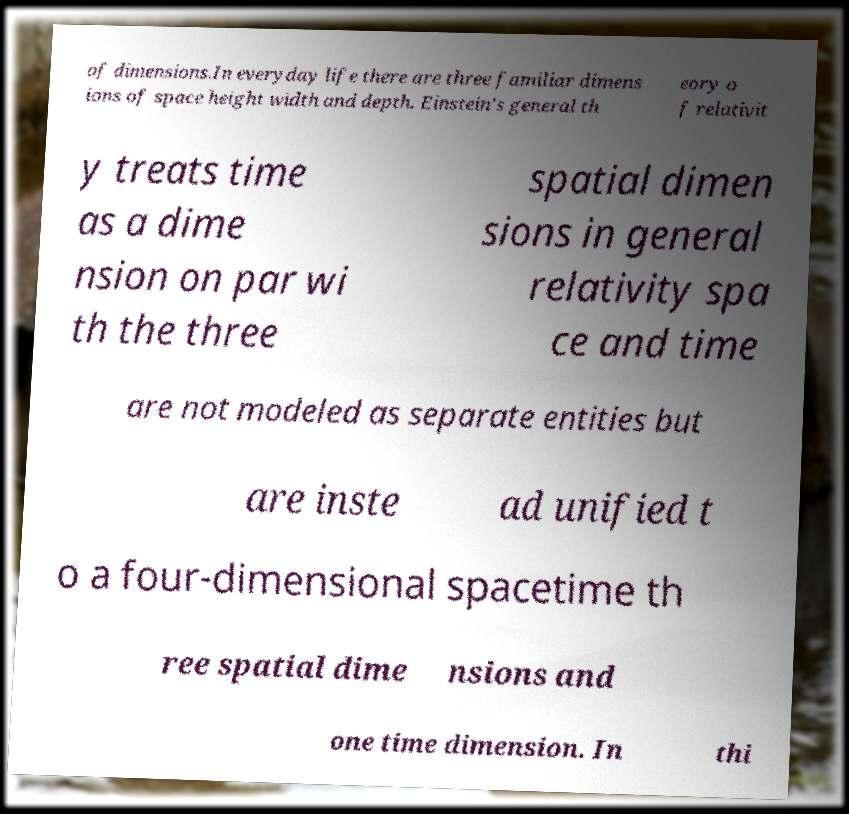Can you read and provide the text displayed in the image?This photo seems to have some interesting text. Can you extract and type it out for me? of dimensions.In everyday life there are three familiar dimens ions of space height width and depth. Einstein's general th eory o f relativit y treats time as a dime nsion on par wi th the three spatial dimen sions in general relativity spa ce and time are not modeled as separate entities but are inste ad unified t o a four-dimensional spacetime th ree spatial dime nsions and one time dimension. In thi 